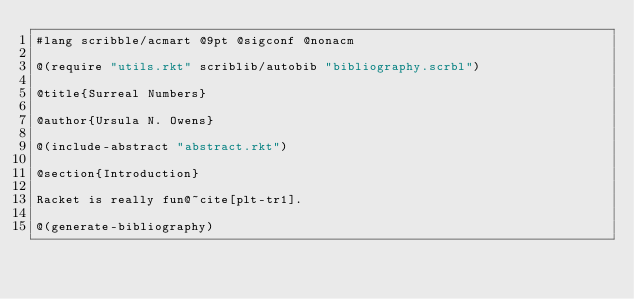<code> <loc_0><loc_0><loc_500><loc_500><_Racket_>#lang scribble/acmart @9pt @sigconf @nonacm

@(require "utils.rkt" scriblib/autobib "bibliography.scrbl")

@title{Surreal Numbers}

@author{Ursula N. Owens}

@(include-abstract "abstract.rkt")

@section{Introduction}

Racket is really fun@~cite[plt-tr1].

@(generate-bibliography)
</code> 